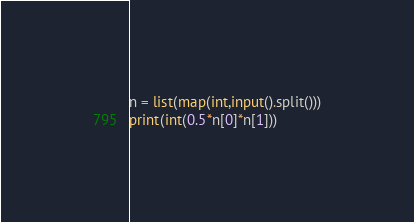Convert code to text. <code><loc_0><loc_0><loc_500><loc_500><_Python_>n = list(map(int,input().split()))
print(int(0.5*n[0]*n[1]))</code> 